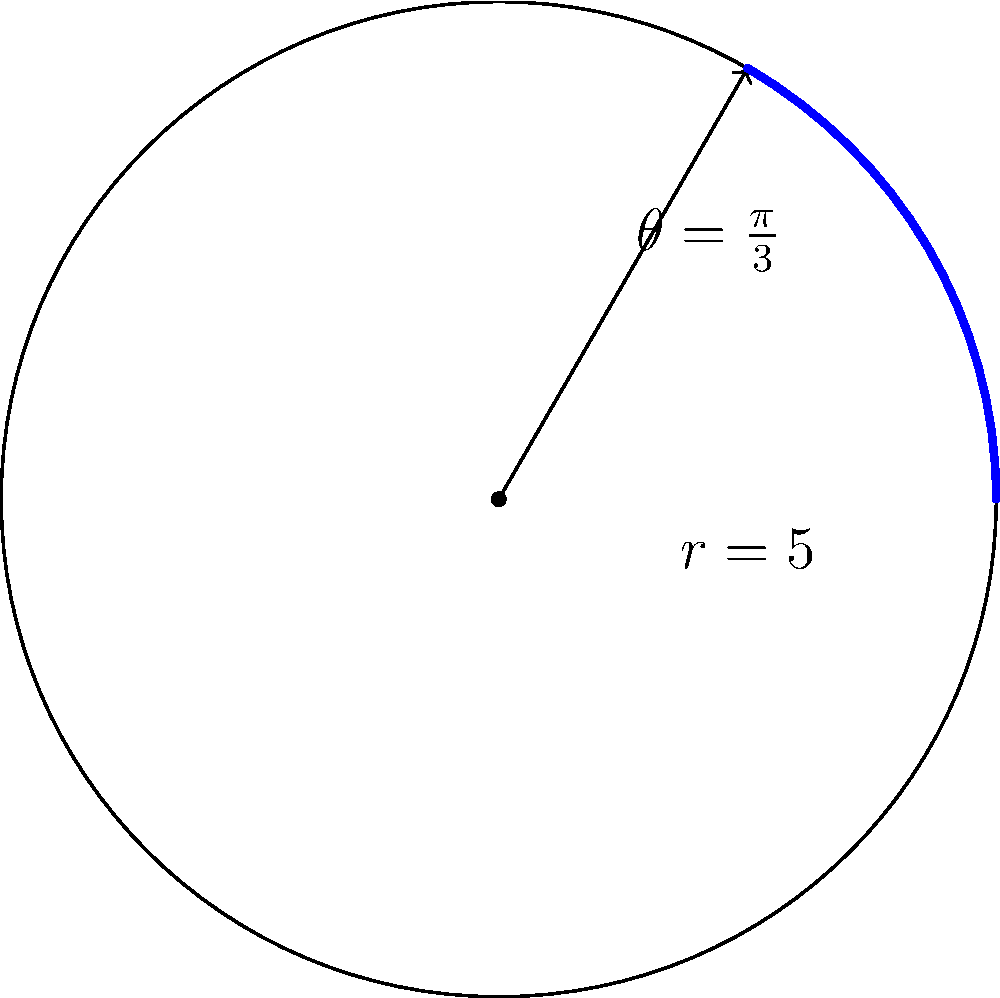A circular luggage storage facility has a radius of 5 meters. If the coverage area spans an angle of $\frac{\pi}{3}$ radians, what is the area of the storage space in square meters? To find the area of a sector of a circle, we can use the formula:

$$A = \frac{1}{2}r^2\theta$$

Where:
$A$ is the area of the sector
$r$ is the radius of the circle
$\theta$ is the angle in radians

Given:
$r = 5$ meters
$\theta = \frac{\pi}{3}$ radians

Let's substitute these values into the formula:

$$A = \frac{1}{2} \cdot 5^2 \cdot \frac{\pi}{3}$$

$$A = \frac{1}{2} \cdot 25 \cdot \frac{\pi}{3}$$

$$A = \frac{25\pi}{6}$$

Therefore, the area of the storage space is $\frac{25\pi}{6}$ square meters.
Answer: $\frac{25\pi}{6}$ square meters 